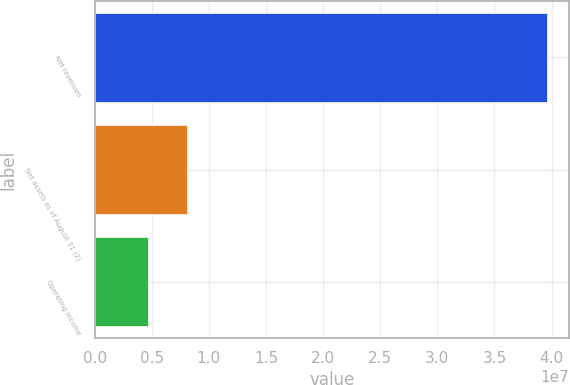<chart> <loc_0><loc_0><loc_500><loc_500><bar_chart><fcel>Net revenues<fcel>Net assets as of August 31 (2)<fcel>Operating income<nl><fcel>3.95734e+07<fcel>8.12669e+06<fcel>4.63261e+06<nl></chart> 